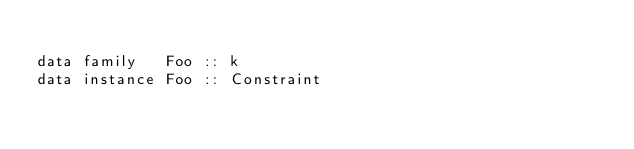Convert code to text. <code><loc_0><loc_0><loc_500><loc_500><_Haskell_>
data family   Foo :: k
data instance Foo :: Constraint
</code> 